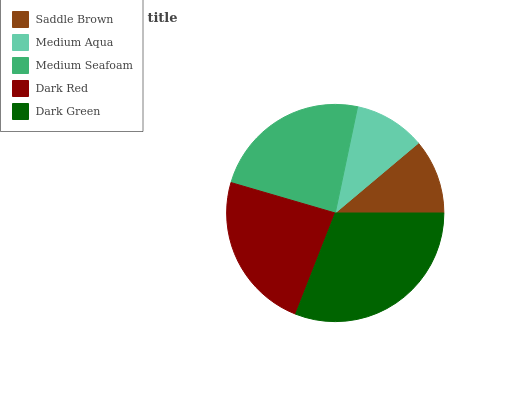Is Medium Aqua the minimum?
Answer yes or no. Yes. Is Dark Green the maximum?
Answer yes or no. Yes. Is Medium Seafoam the minimum?
Answer yes or no. No. Is Medium Seafoam the maximum?
Answer yes or no. No. Is Medium Seafoam greater than Medium Aqua?
Answer yes or no. Yes. Is Medium Aqua less than Medium Seafoam?
Answer yes or no. Yes. Is Medium Aqua greater than Medium Seafoam?
Answer yes or no. No. Is Medium Seafoam less than Medium Aqua?
Answer yes or no. No. Is Dark Red the high median?
Answer yes or no. Yes. Is Dark Red the low median?
Answer yes or no. Yes. Is Medium Seafoam the high median?
Answer yes or no. No. Is Medium Seafoam the low median?
Answer yes or no. No. 